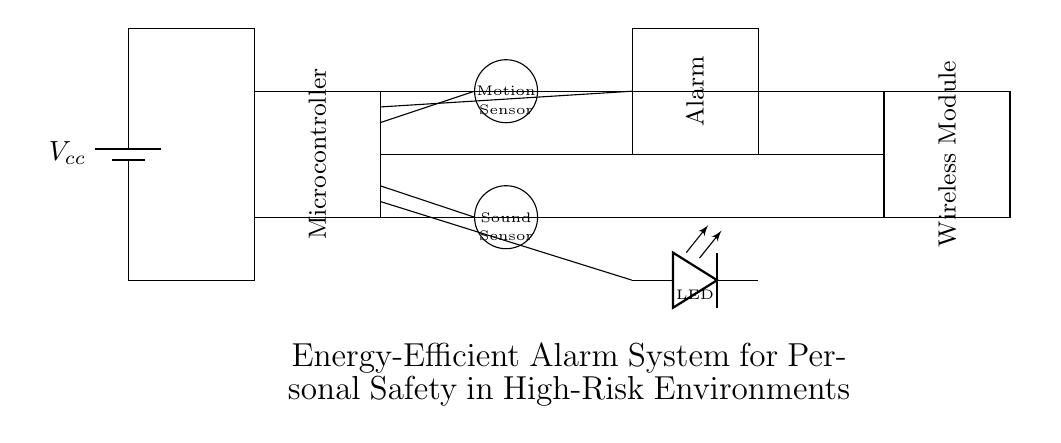What is the main power source for this circuit? The main power source is a battery labeled as Vcc. In the circuit diagram, it is positioned at the top left and supplies power to the rest of the components.
Answer: Battery What type of sensor is used for detecting movement? The circuit includes a motion sensor represented by a circle, labeled "Motion Sensor." Its placement indicates it is responsible for detecting motion.
Answer: Motion sensor How many types of sensors are present in the circuit? There are two types of sensors: a motion sensor and a sound sensor. The diagram clearly labels both sensors separately.
Answer: Two What is the purpose of the LED in the circuit? The LED serves as an indicator, signaling the status of the alarm system. Its placement indicates it's connected to the alerting mechanism of the system.
Answer: Indicator What component connects to the wireless module? The circuit diagram shows a connection from the microcontroller to the wireless module to facilitate communication, indicating its role in transmitting signals remotely.
Answer: Microcontroller What signifies the energy efficiency of this alarm system? The use of low-power components like sensors and a wireless module highlights the design focus on minimizing power consumption while ensuring safety.
Answer: Low-power components 